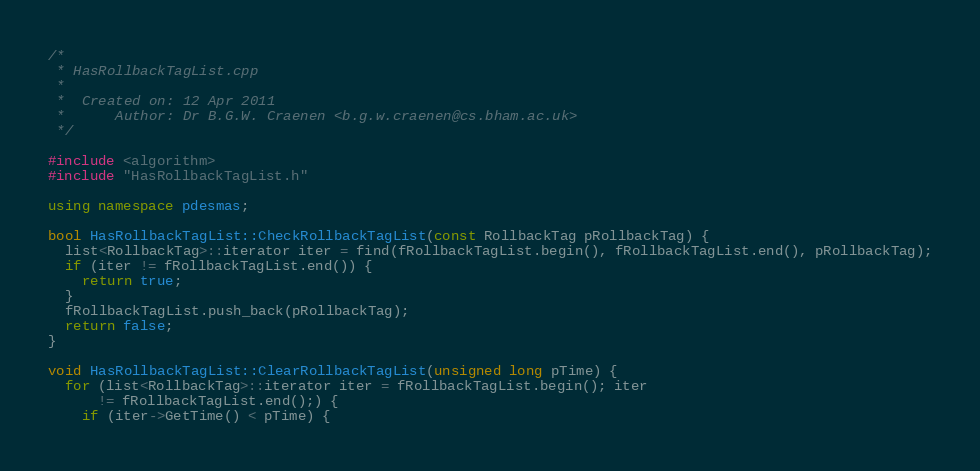<code> <loc_0><loc_0><loc_500><loc_500><_C++_>/*
 * HasRollbackTagList.cpp
 *
 *  Created on: 12 Apr 2011
 *      Author: Dr B.G.W. Craenen <b.g.w.craenen@cs.bham.ac.uk>
 */

#include <algorithm>
#include "HasRollbackTagList.h"

using namespace pdesmas;

bool HasRollbackTagList::CheckRollbackTagList(const RollbackTag pRollbackTag) {
  list<RollbackTag>::iterator iter = find(fRollbackTagList.begin(), fRollbackTagList.end(), pRollbackTag);
  if (iter != fRollbackTagList.end()) {
    return true;
  }
  fRollbackTagList.push_back(pRollbackTag);
  return false;
}

void HasRollbackTagList::ClearRollbackTagList(unsigned long pTime) {
  for (list<RollbackTag>::iterator iter = fRollbackTagList.begin(); iter
      != fRollbackTagList.end();) {
    if (iter->GetTime() < pTime) {</code> 